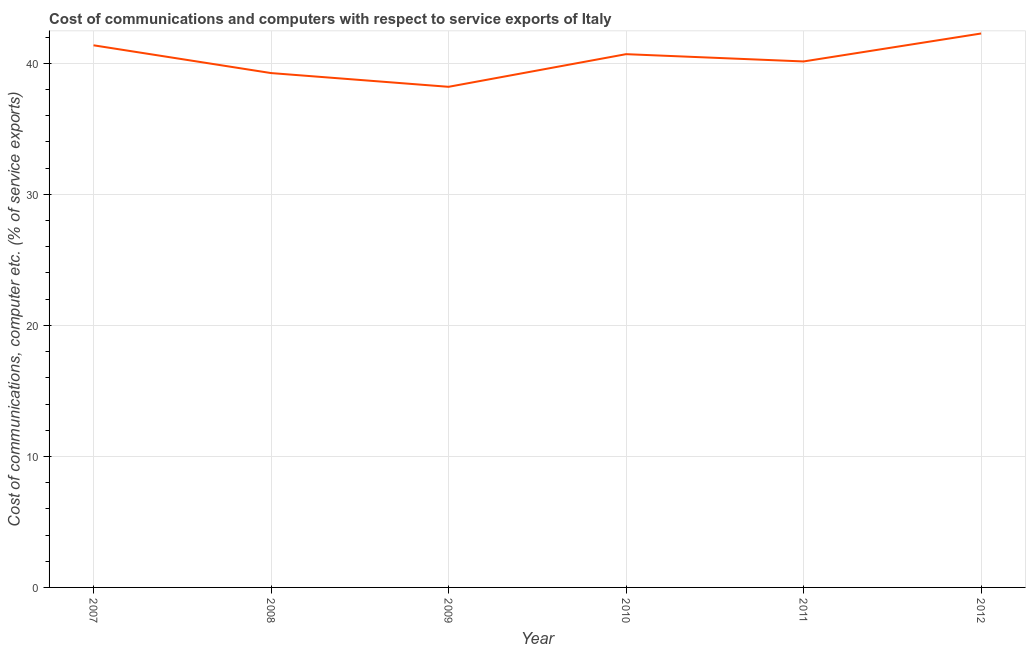What is the cost of communications and computer in 2008?
Ensure brevity in your answer.  39.26. Across all years, what is the maximum cost of communications and computer?
Provide a succinct answer. 42.28. Across all years, what is the minimum cost of communications and computer?
Your answer should be compact. 38.21. In which year was the cost of communications and computer maximum?
Offer a very short reply. 2012. In which year was the cost of communications and computer minimum?
Make the answer very short. 2009. What is the sum of the cost of communications and computer?
Your answer should be very brief. 241.98. What is the difference between the cost of communications and computer in 2008 and 2012?
Your answer should be compact. -3.02. What is the average cost of communications and computer per year?
Keep it short and to the point. 40.33. What is the median cost of communications and computer?
Make the answer very short. 40.43. What is the ratio of the cost of communications and computer in 2007 to that in 2009?
Give a very brief answer. 1.08. What is the difference between the highest and the second highest cost of communications and computer?
Provide a succinct answer. 0.9. Is the sum of the cost of communications and computer in 2009 and 2011 greater than the maximum cost of communications and computer across all years?
Your answer should be compact. Yes. What is the difference between the highest and the lowest cost of communications and computer?
Offer a terse response. 4.07. In how many years, is the cost of communications and computer greater than the average cost of communications and computer taken over all years?
Keep it short and to the point. 3. How many years are there in the graph?
Offer a very short reply. 6. Are the values on the major ticks of Y-axis written in scientific E-notation?
Your answer should be compact. No. Does the graph contain any zero values?
Give a very brief answer. No. What is the title of the graph?
Give a very brief answer. Cost of communications and computers with respect to service exports of Italy. What is the label or title of the Y-axis?
Make the answer very short. Cost of communications, computer etc. (% of service exports). What is the Cost of communications, computer etc. (% of service exports) in 2007?
Offer a terse response. 41.38. What is the Cost of communications, computer etc. (% of service exports) in 2008?
Your response must be concise. 39.26. What is the Cost of communications, computer etc. (% of service exports) in 2009?
Make the answer very short. 38.21. What is the Cost of communications, computer etc. (% of service exports) of 2010?
Your response must be concise. 40.7. What is the Cost of communications, computer etc. (% of service exports) of 2011?
Provide a short and direct response. 40.15. What is the Cost of communications, computer etc. (% of service exports) of 2012?
Your response must be concise. 42.28. What is the difference between the Cost of communications, computer etc. (% of service exports) in 2007 and 2008?
Offer a very short reply. 2.12. What is the difference between the Cost of communications, computer etc. (% of service exports) in 2007 and 2009?
Ensure brevity in your answer.  3.17. What is the difference between the Cost of communications, computer etc. (% of service exports) in 2007 and 2010?
Offer a very short reply. 0.68. What is the difference between the Cost of communications, computer etc. (% of service exports) in 2007 and 2011?
Give a very brief answer. 1.23. What is the difference between the Cost of communications, computer etc. (% of service exports) in 2007 and 2012?
Provide a short and direct response. -0.9. What is the difference between the Cost of communications, computer etc. (% of service exports) in 2008 and 2009?
Provide a succinct answer. 1.05. What is the difference between the Cost of communications, computer etc. (% of service exports) in 2008 and 2010?
Give a very brief answer. -1.44. What is the difference between the Cost of communications, computer etc. (% of service exports) in 2008 and 2011?
Offer a terse response. -0.89. What is the difference between the Cost of communications, computer etc. (% of service exports) in 2008 and 2012?
Provide a succinct answer. -3.02. What is the difference between the Cost of communications, computer etc. (% of service exports) in 2009 and 2010?
Your response must be concise. -2.49. What is the difference between the Cost of communications, computer etc. (% of service exports) in 2009 and 2011?
Offer a terse response. -1.94. What is the difference between the Cost of communications, computer etc. (% of service exports) in 2009 and 2012?
Offer a terse response. -4.07. What is the difference between the Cost of communications, computer etc. (% of service exports) in 2010 and 2011?
Provide a succinct answer. 0.56. What is the difference between the Cost of communications, computer etc. (% of service exports) in 2010 and 2012?
Your answer should be compact. -1.58. What is the difference between the Cost of communications, computer etc. (% of service exports) in 2011 and 2012?
Provide a short and direct response. -2.13. What is the ratio of the Cost of communications, computer etc. (% of service exports) in 2007 to that in 2008?
Your answer should be compact. 1.05. What is the ratio of the Cost of communications, computer etc. (% of service exports) in 2007 to that in 2009?
Keep it short and to the point. 1.08. What is the ratio of the Cost of communications, computer etc. (% of service exports) in 2007 to that in 2010?
Your response must be concise. 1.02. What is the ratio of the Cost of communications, computer etc. (% of service exports) in 2007 to that in 2011?
Make the answer very short. 1.03. What is the ratio of the Cost of communications, computer etc. (% of service exports) in 2008 to that in 2010?
Your answer should be very brief. 0.96. What is the ratio of the Cost of communications, computer etc. (% of service exports) in 2008 to that in 2011?
Offer a very short reply. 0.98. What is the ratio of the Cost of communications, computer etc. (% of service exports) in 2008 to that in 2012?
Provide a short and direct response. 0.93. What is the ratio of the Cost of communications, computer etc. (% of service exports) in 2009 to that in 2010?
Provide a succinct answer. 0.94. What is the ratio of the Cost of communications, computer etc. (% of service exports) in 2009 to that in 2011?
Keep it short and to the point. 0.95. What is the ratio of the Cost of communications, computer etc. (% of service exports) in 2009 to that in 2012?
Ensure brevity in your answer.  0.9. What is the ratio of the Cost of communications, computer etc. (% of service exports) in 2010 to that in 2011?
Provide a short and direct response. 1.01. What is the ratio of the Cost of communications, computer etc. (% of service exports) in 2010 to that in 2012?
Offer a very short reply. 0.96. 